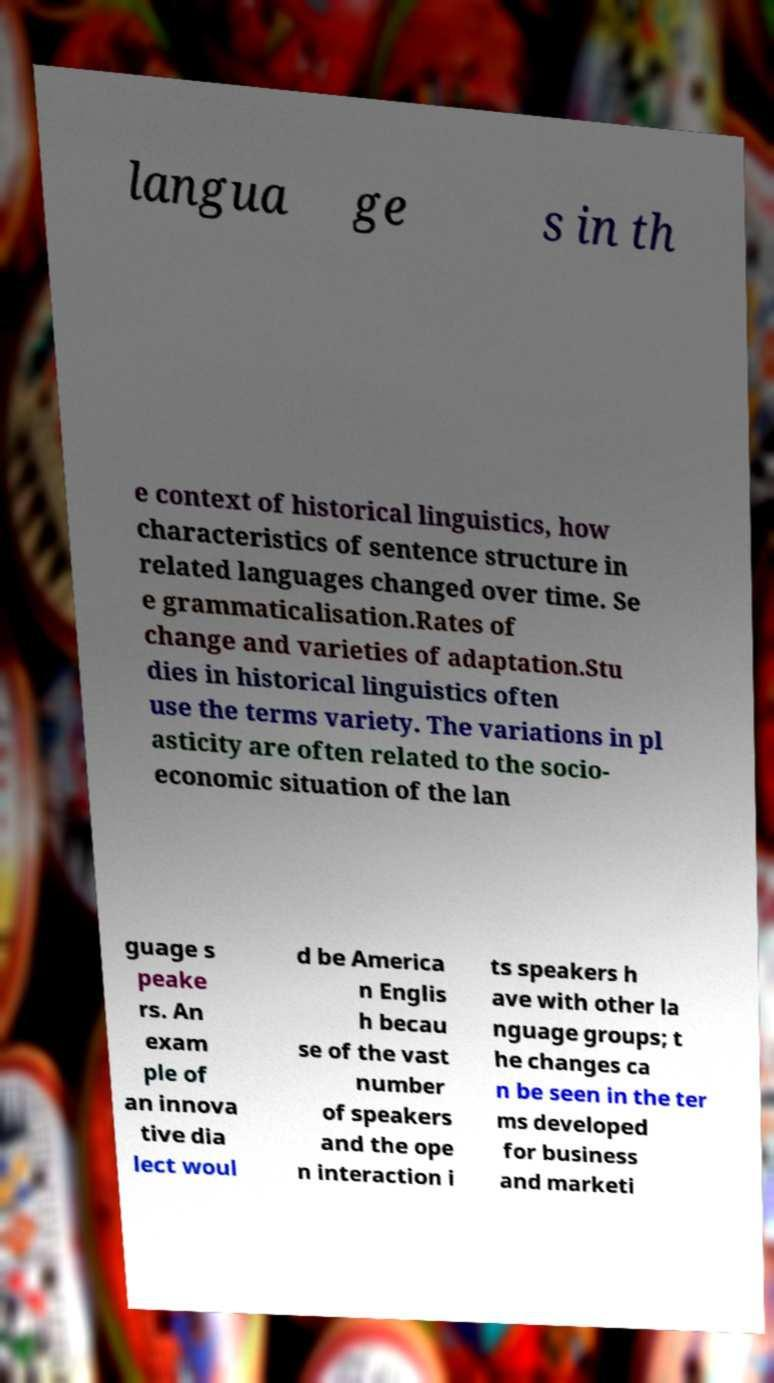Please identify and transcribe the text found in this image. langua ge s in th e context of historical linguistics, how characteristics of sentence structure in related languages changed over time. Se e grammaticalisation.Rates of change and varieties of adaptation.Stu dies in historical linguistics often use the terms variety. The variations in pl asticity are often related to the socio- economic situation of the lan guage s peake rs. An exam ple of an innova tive dia lect woul d be America n Englis h becau se of the vast number of speakers and the ope n interaction i ts speakers h ave with other la nguage groups; t he changes ca n be seen in the ter ms developed for business and marketi 